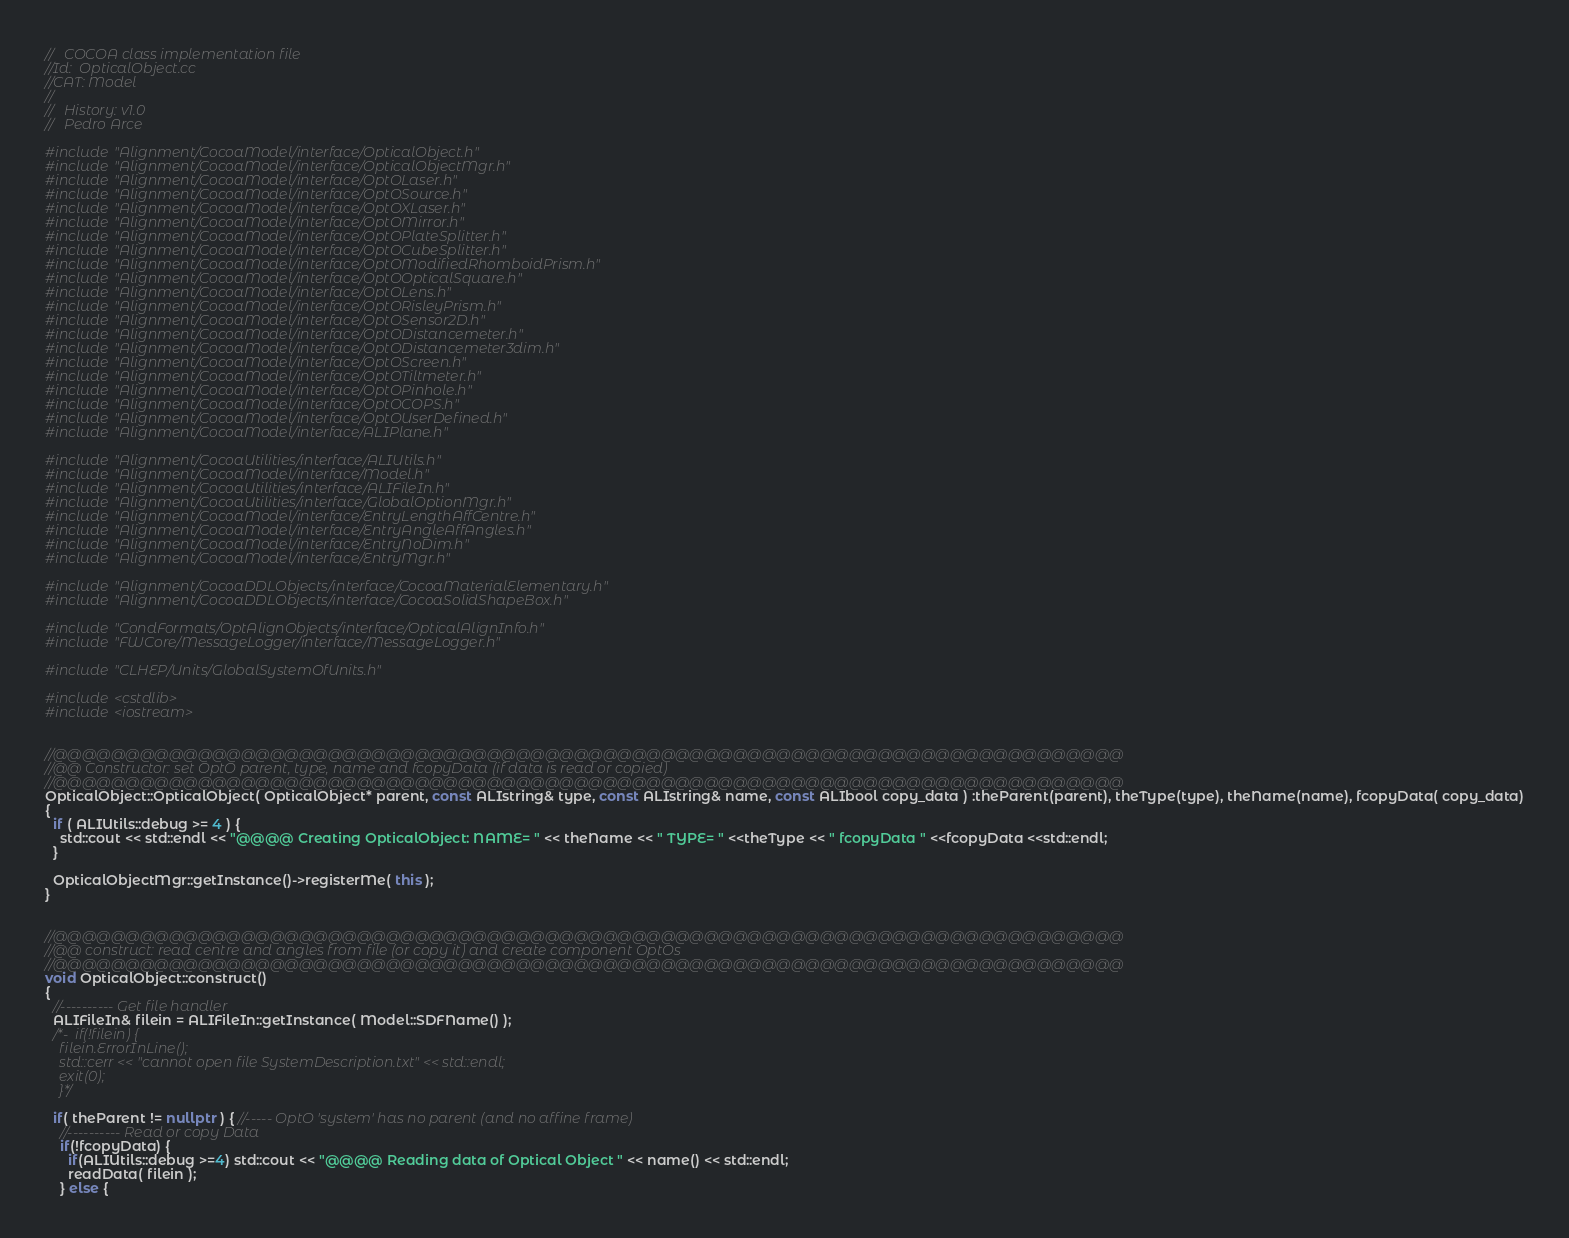Convert code to text. <code><loc_0><loc_0><loc_500><loc_500><_C++_>//   COCOA class implementation file
//Id:  OpticalObject.cc
//CAT: Model
//
//   History: v1.0
//   Pedro Arce

#include "Alignment/CocoaModel/interface/OpticalObject.h"
#include "Alignment/CocoaModel/interface/OpticalObjectMgr.h"
#include "Alignment/CocoaModel/interface/OptOLaser.h"
#include "Alignment/CocoaModel/interface/OptOSource.h"
#include "Alignment/CocoaModel/interface/OptOXLaser.h"
#include "Alignment/CocoaModel/interface/OptOMirror.h"
#include "Alignment/CocoaModel/interface/OptOPlateSplitter.h"
#include "Alignment/CocoaModel/interface/OptOCubeSplitter.h"
#include "Alignment/CocoaModel/interface/OptOModifiedRhomboidPrism.h"
#include "Alignment/CocoaModel/interface/OptOOpticalSquare.h"
#include "Alignment/CocoaModel/interface/OptOLens.h"
#include "Alignment/CocoaModel/interface/OptORisleyPrism.h"
#include "Alignment/CocoaModel/interface/OptOSensor2D.h"
#include "Alignment/CocoaModel/interface/OptODistancemeter.h"
#include "Alignment/CocoaModel/interface/OptODistancemeter3dim.h"
#include "Alignment/CocoaModel/interface/OptOScreen.h"
#include "Alignment/CocoaModel/interface/OptOTiltmeter.h"
#include "Alignment/CocoaModel/interface/OptOPinhole.h"
#include "Alignment/CocoaModel/interface/OptOCOPS.h"
#include "Alignment/CocoaModel/interface/OptOUserDefined.h"
#include "Alignment/CocoaModel/interface/ALIPlane.h"

#include "Alignment/CocoaUtilities/interface/ALIUtils.h"
#include "Alignment/CocoaModel/interface/Model.h"
#include "Alignment/CocoaUtilities/interface/ALIFileIn.h"
#include "Alignment/CocoaUtilities/interface/GlobalOptionMgr.h"
#include "Alignment/CocoaModel/interface/EntryLengthAffCentre.h"
#include "Alignment/CocoaModel/interface/EntryAngleAffAngles.h"
#include "Alignment/CocoaModel/interface/EntryNoDim.h"
#include "Alignment/CocoaModel/interface/EntryMgr.h"

#include "Alignment/CocoaDDLObjects/interface/CocoaMaterialElementary.h"
#include "Alignment/CocoaDDLObjects/interface/CocoaSolidShapeBox.h"

#include "CondFormats/OptAlignObjects/interface/OpticalAlignInfo.h"
#include "FWCore/MessageLogger/interface/MessageLogger.h"

#include "CLHEP/Units/GlobalSystemOfUnits.h"

#include <cstdlib>
#include <iostream>


//@@@@@@@@@@@@@@@@@@@@@@@@@@@@@@@@@@@@@@@@@@@@@@@@@@@@@@@@@@@@@@@@@@@@@@@@@@
//@@ Constructor: set OptO parent, type, name and fcopyData (if data is read or copied)
//@@@@@@@@@@@@@@@@@@@@@@@@@@@@@@@@@@@@@@@@@@@@@@@@@@@@@@@@@@@@@@@@@@@@@@@@@@
OpticalObject::OpticalObject( OpticalObject* parent, const ALIstring& type, const ALIstring& name, const ALIbool copy_data ) :theParent(parent), theType(type), theName(name), fcopyData( copy_data)
{
  if ( ALIUtils::debug >= 4 ) {
    std::cout << std::endl << "@@@@ Creating OpticalObject: NAME= " << theName << " TYPE= " <<theType << " fcopyData " <<fcopyData <<std::endl;
  }

  OpticalObjectMgr::getInstance()->registerMe( this );
}


//@@@@@@@@@@@@@@@@@@@@@@@@@@@@@@@@@@@@@@@@@@@@@@@@@@@@@@@@@@@@@@@@@@@@@@@@@@
//@@ construct: read centre and angles from file (or copy it) and create component OptOs
//@@@@@@@@@@@@@@@@@@@@@@@@@@@@@@@@@@@@@@@@@@@@@@@@@@@@@@@@@@@@@@@@@@@@@@@@@@
void OpticalObject::construct()
{
  //---------- Get file handler
  ALIFileIn& filein = ALIFileIn::getInstance( Model::SDFName() );
  /*-  if(!filein) {
    filein.ErrorInLine();
    std::cerr << "cannot open file SystemDescription.txt" << std::endl;
    exit(0);
    }*/

  if( theParent != nullptr ) { //----- OptO 'system' has no parent (and no affine frame)
    //---------- Read or copy Data
    if(!fcopyData) {
      if(ALIUtils::debug >=4) std::cout << "@@@@ Reading data of Optical Object " << name() << std::endl;
      readData( filein );
    } else {</code> 